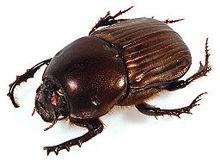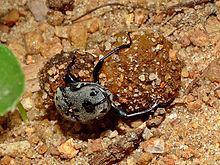The first image is the image on the left, the second image is the image on the right. For the images displayed, is the sentence "An image shows a beetle atop a dung ball, so its body is parallel with the ground." factually correct? Answer yes or no. No. 